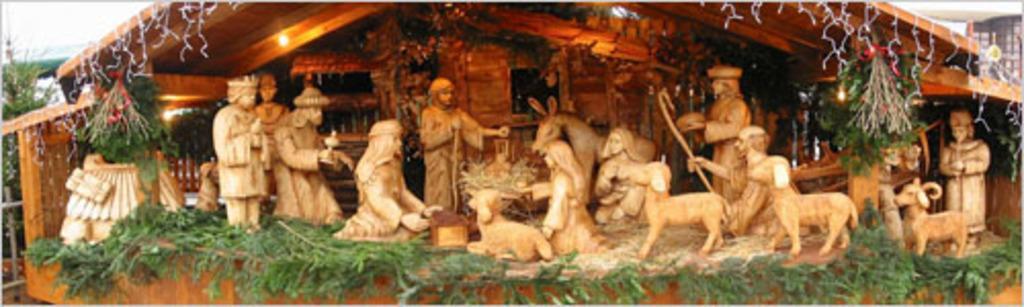Describe this image in one or two sentences. In this picture we can see there are sculptures of people and animals in the small wooden house and in the house there are lights and leaves. Behind the house there is a tree and it looks like the sky. 